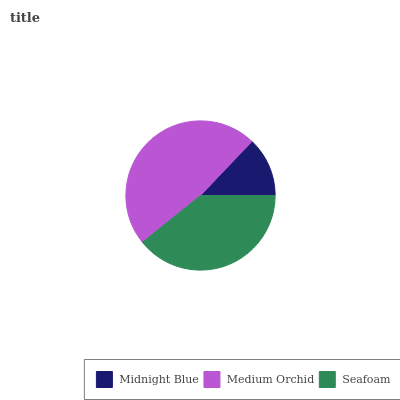Is Midnight Blue the minimum?
Answer yes or no. Yes. Is Medium Orchid the maximum?
Answer yes or no. Yes. Is Seafoam the minimum?
Answer yes or no. No. Is Seafoam the maximum?
Answer yes or no. No. Is Medium Orchid greater than Seafoam?
Answer yes or no. Yes. Is Seafoam less than Medium Orchid?
Answer yes or no. Yes. Is Seafoam greater than Medium Orchid?
Answer yes or no. No. Is Medium Orchid less than Seafoam?
Answer yes or no. No. Is Seafoam the high median?
Answer yes or no. Yes. Is Seafoam the low median?
Answer yes or no. Yes. Is Medium Orchid the high median?
Answer yes or no. No. Is Midnight Blue the low median?
Answer yes or no. No. 